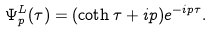Convert formula to latex. <formula><loc_0><loc_0><loc_500><loc_500>\Psi _ { p } ^ { L } ( \tau ) = ( \coth \tau + i p ) e ^ { - i p \tau } .</formula> 